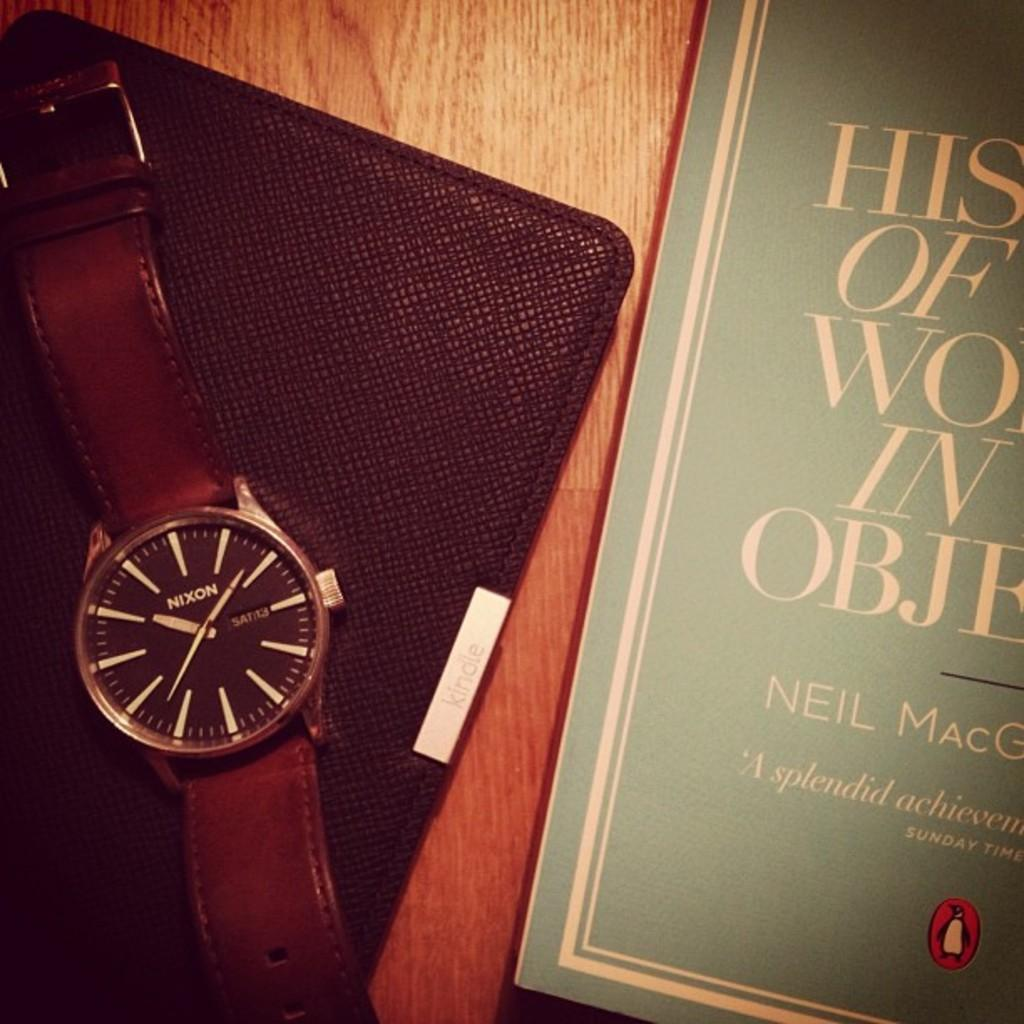<image>
Offer a succinct explanation of the picture presented. Book next to a watch that says the word NIXON on it. 